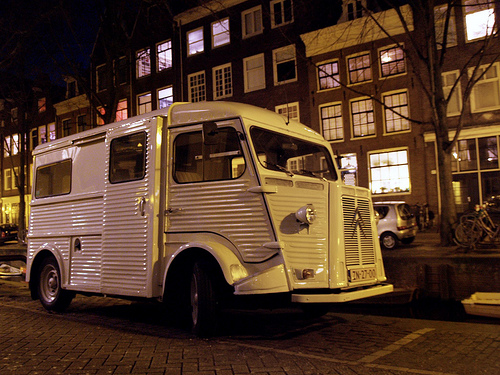<image>
Is there a car above the water? No. The car is not positioned above the water. The vertical arrangement shows a different relationship. 